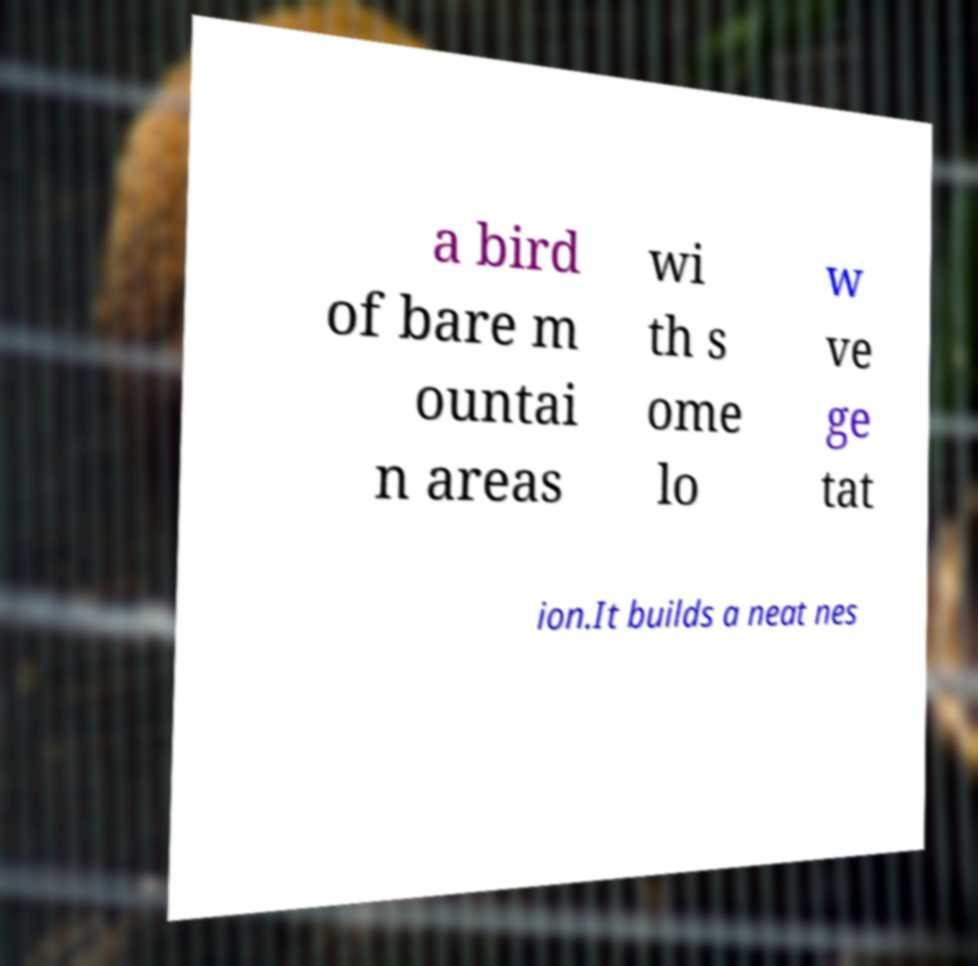For documentation purposes, I need the text within this image transcribed. Could you provide that? a bird of bare m ountai n areas wi th s ome lo w ve ge tat ion.It builds a neat nes 